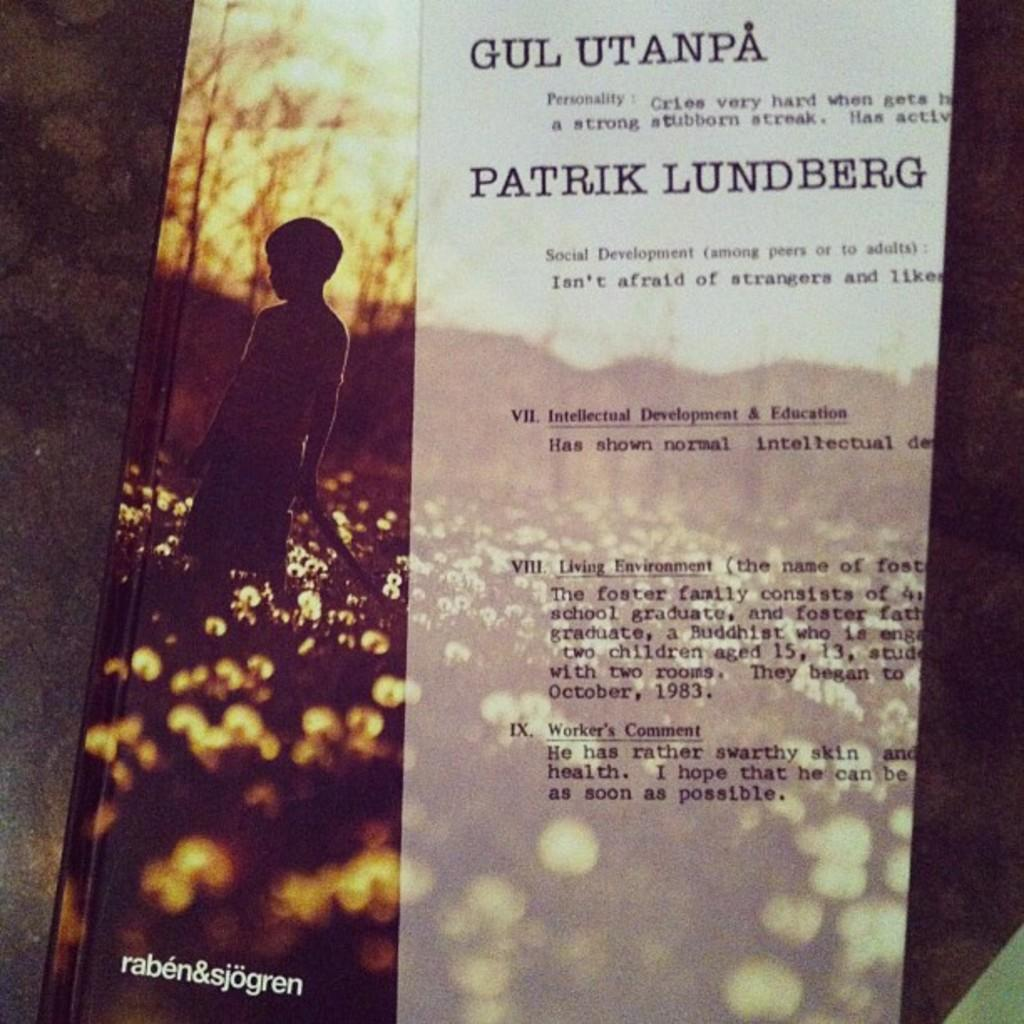<image>
Create a compact narrative representing the image presented. a book with the name Patrik Lundberg on it 